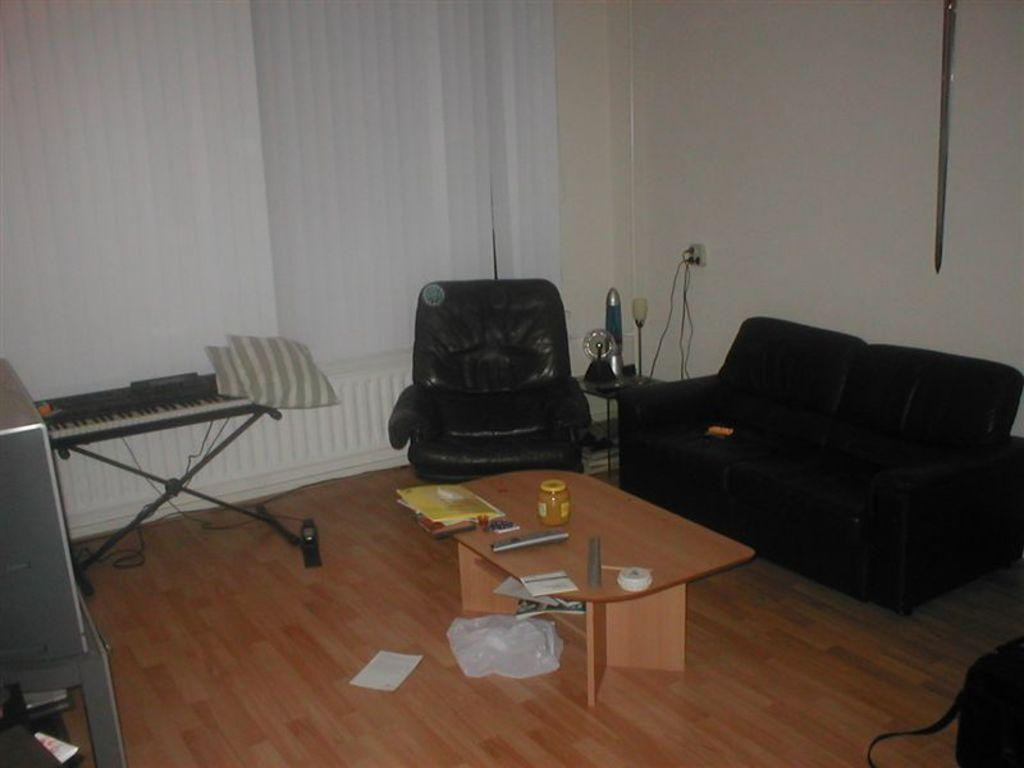What type of furniture is in the room? There is a couch in the room. What can be used for entertainment in the room? There is a musical instrument in the room. What type of container is in the room? There is a bottle in the room. What device is on top of a table in the room? There is a remote on top of a table in the room. What type of window treatment is in the room? There are white curtains in the room. How many light bulbs are visible in the room? There is no mention of light bulbs in the provided facts, so we cannot determine the number of bulbs in the room. What type of bathtub is in the room? There is no mention of a bathtub in the provided facts, so we cannot determine if there is a tub in the room. 